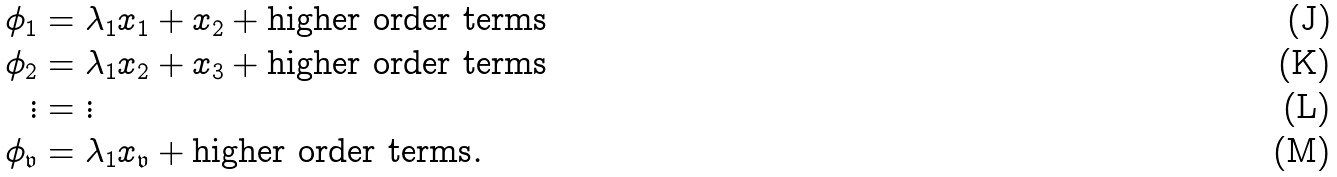<formula> <loc_0><loc_0><loc_500><loc_500>\phi _ { 1 } & = \lambda _ { 1 } x _ { 1 } + x _ { 2 } + \text {higher order terms} \\ \phi _ { 2 } & = \lambda _ { 1 } x _ { 2 } + x _ { 3 } + \text {higher order terms} \\ \vdots & = \vdots \\ \phi _ { \mathfrak { v } } & = \lambda _ { 1 } x _ { \mathfrak { v } } + \text {higher order terms} .</formula> 